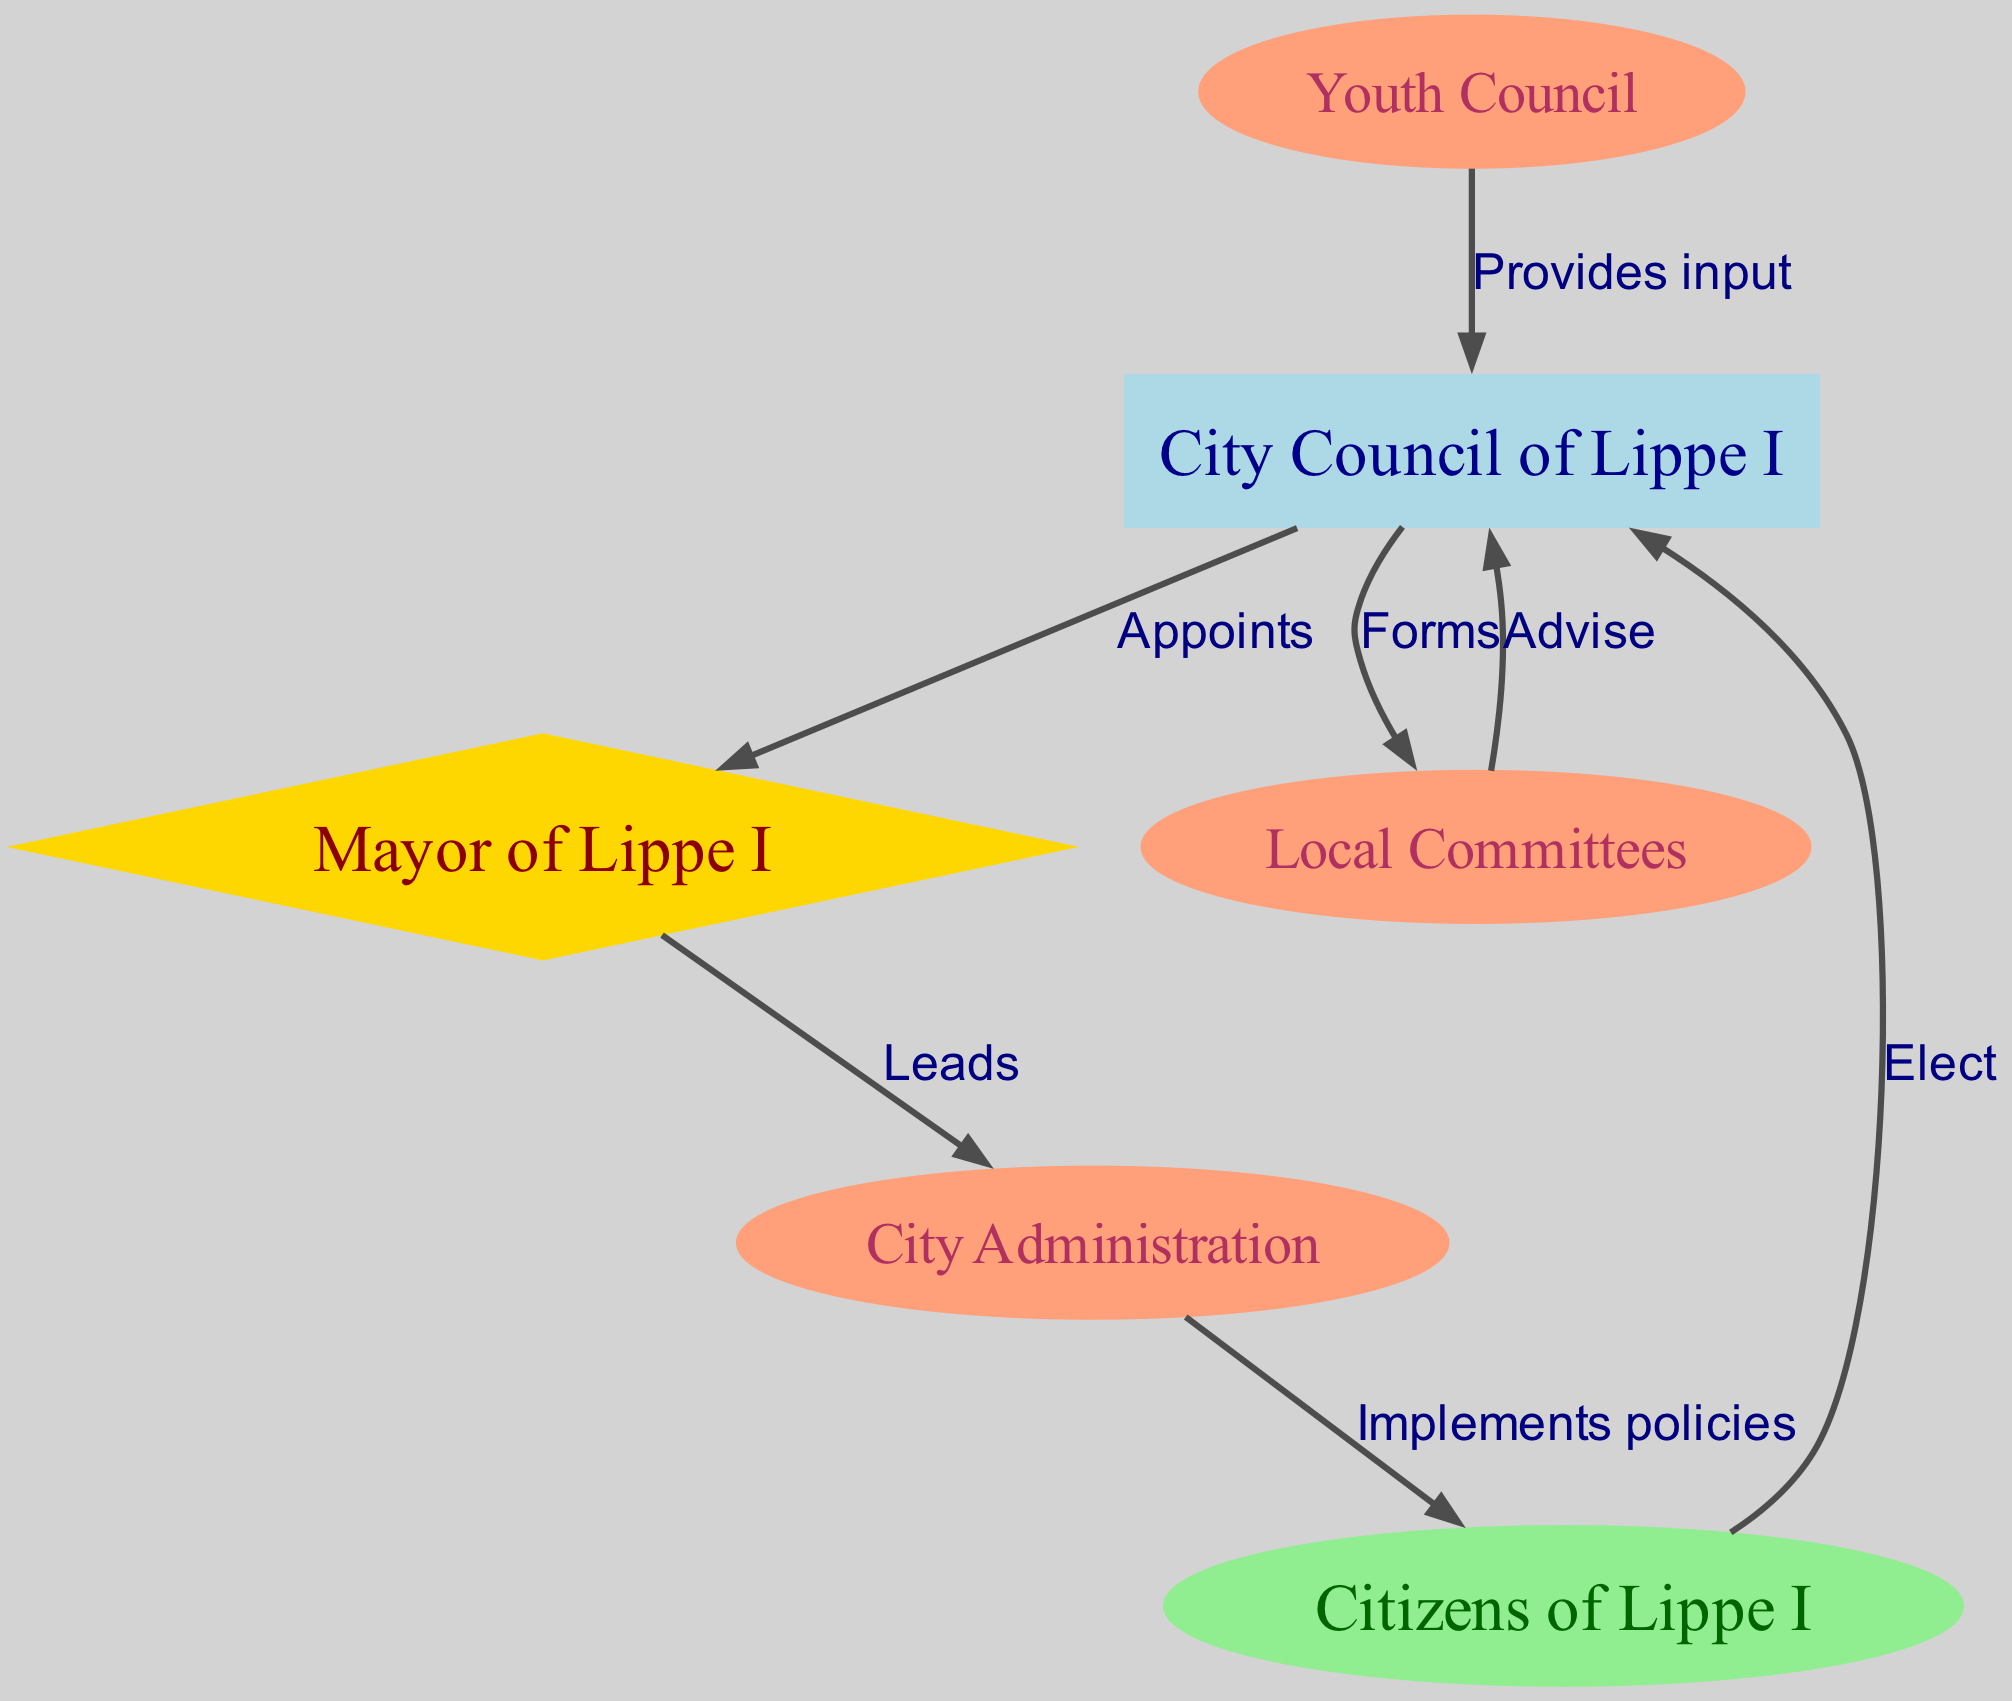What is the primary role of the City Council of Lippe I? The primary role of the City Council of Lippe I is to oversee local government decision-making, as indicated by its connections to various nodes such as electing representatives, forming committees, and receiving advice.
Answer: Oversee local government Who appoints the Mayor of Lippe I? According to the diagram, the City Council of Lippe I appoints the Mayor of Lippe I, as shown by the edge labeled "Appoints."
Answer: City Council of Lippe I How do Citizens of Lippe I influence the City Council of Lippe I? Citizens of Lippe I influence the City Council of Lippe I by electing them, which is clearly represented by the directed edge labeled "Elect."
Answer: Elect What does the Mayor of Lippe I lead? The Mayor of Lippe I leads the City Administration, as indicated by the directed edge that flows from the Mayor to the City Administration labeled "Leads."
Answer: City Administration How many local committees are directly connected to the City Council of Lippe I? There is one directed edge from the City Council of Lippe I to the Local Committees, indicating that the City Council forms these committees. Hence, there is one local committee connected.
Answer: One What input does the Youth Council provide to the City Council of Lippe I? The Youth Council provides input to the City Council of Lippe I, as represented by the directed edge that communicates this relationship with the label "Provides input."
Answer: Input What is the flow of policies from the City Administration to the citizens? The flow occurs through the directed edge from the City Administration to the Citizens of Lippe I labeled "Implements policies," indicating that the City Administration is responsible for this action towards citizens.
Answer: Implements policies Which node has a bi-directional relationship with the Local Committees? The Local Committees have a directed edge leading to the City Council of Lippe I, where they advise the council, and the council forms these committees, demonstrating a bi-directional relationship in the decision-making process.
Answer: City Council of Lippe I How many total nodes are there in the diagram? The total number of nodes in the diagram is six, which includes the City Council of Lippe I, Mayor of Lippe I, City Administration, Local Committees, Youth Council, and Citizens of Lippe I.
Answer: Six 